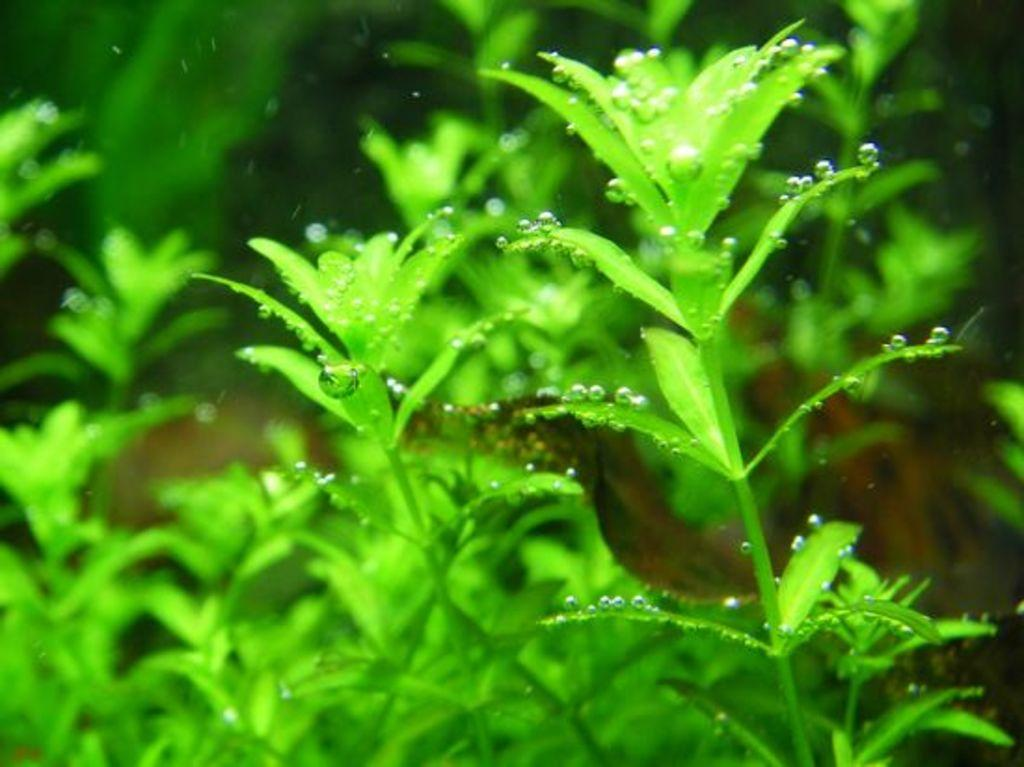What type of living organisms can be seen in the image? Plants can be seen in the image. What can be observed on the plants in the image? There are water droplets on the plants in the image. Can you describe the background of the image? The background of the image is blurred. What type of addition problem can be solved using the marble chess pieces in the image? There are no chess pieces or marbles present in the image, so it is not possible to solve any addition problems using them. 